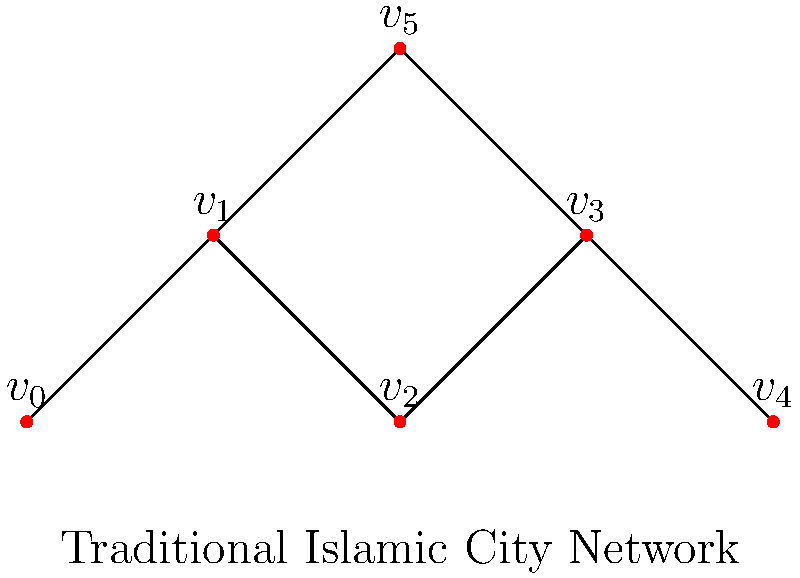In the network graph representing the connectivity of urban spaces in a traditional Islamic city, what is the minimum number of edges that need to be removed to disconnect vertex $v_5$ (representing a central mosque) from vertex $v_4$ (representing a city gate)? To solve this problem, we need to analyze the paths connecting $v_5$ to $v_4$ in the network:

1. Identify all paths from $v_5$ to $v_4$:
   Path 1: $v_5 - v_3 - v_4$
   Path 2: $v_5 - v_1 - v_2 - v_3 - v_4$
   Path 3: $v_5 - v_3 - v_2 - v_1 - v_0 - v_1 - v_2 - v_3 - v_4$ (longer alternative)

2. Observe that all paths must go through $v_3$.

3. The edge $v_3 - v_4$ is common to all paths.

4. Removing the edge $v_3 - v_4$ will disconnect $v_5$ from $v_4$.

5. No single edge removal other than $v_3 - v_4$ can disconnect $v_5$ from $v_4$.

Therefore, the minimum number of edges that need to be removed to disconnect $v_5$ from $v_4$ is 1.

This reflects the importance of key connectors in Islamic urban design, where certain pathways (like those leading to central mosques or city gates) play crucial roles in the city's connectivity.
Answer: 1 